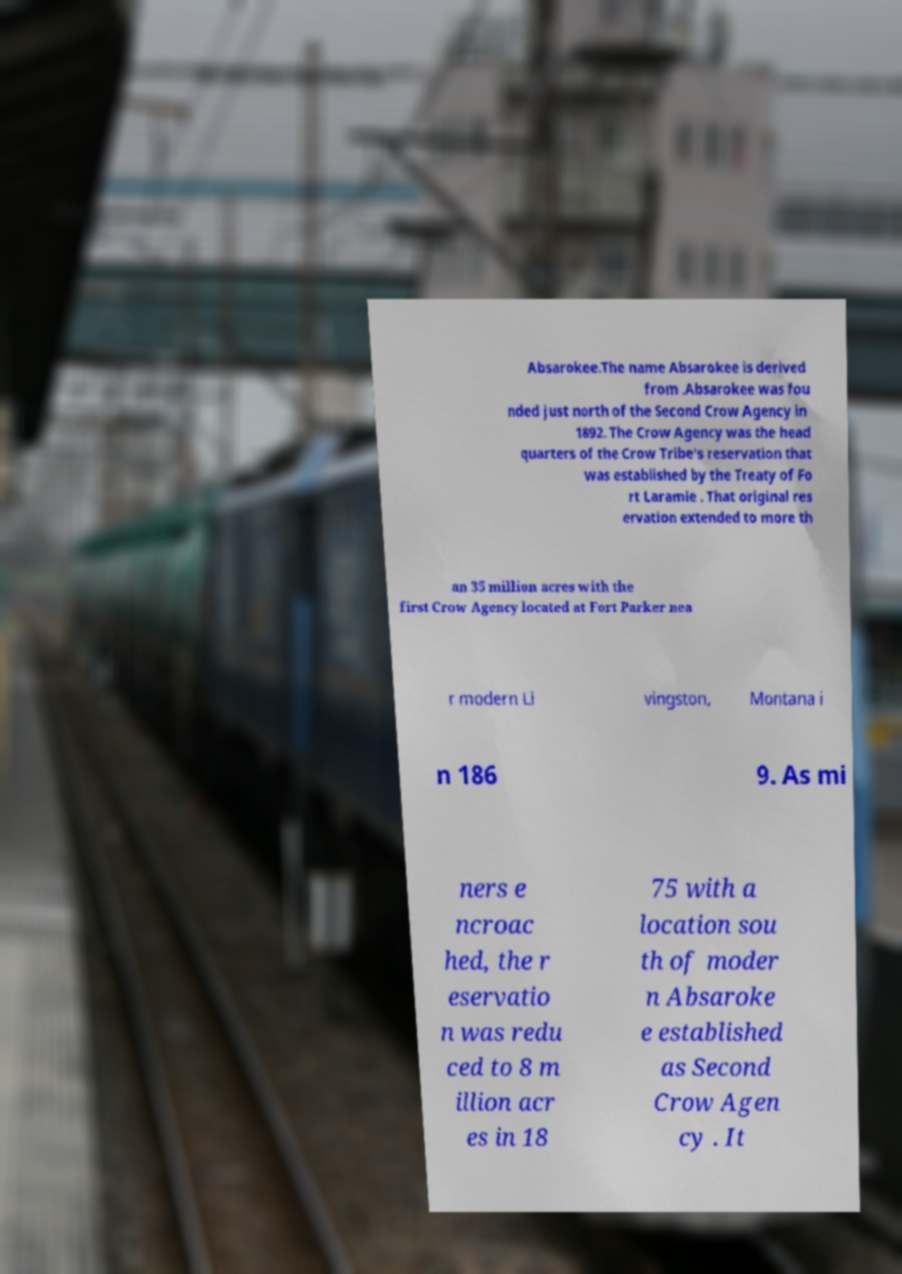Can you read and provide the text displayed in the image?This photo seems to have some interesting text. Can you extract and type it out for me? Absarokee.The name Absarokee is derived from .Absarokee was fou nded just north of the Second Crow Agency in 1892. The Crow Agency was the head quarters of the Crow Tribe's reservation that was established by the Treaty of Fo rt Laramie . That original res ervation extended to more th an 35 million acres with the first Crow Agency located at Fort Parker nea r modern Li vingston, Montana i n 186 9. As mi ners e ncroac hed, the r eservatio n was redu ced to 8 m illion acr es in 18 75 with a location sou th of moder n Absaroke e established as Second Crow Agen cy . It 